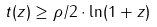Convert formula to latex. <formula><loc_0><loc_0><loc_500><loc_500>t ( z ) \geq \rho / 2 \cdot \ln ( 1 + z )</formula> 